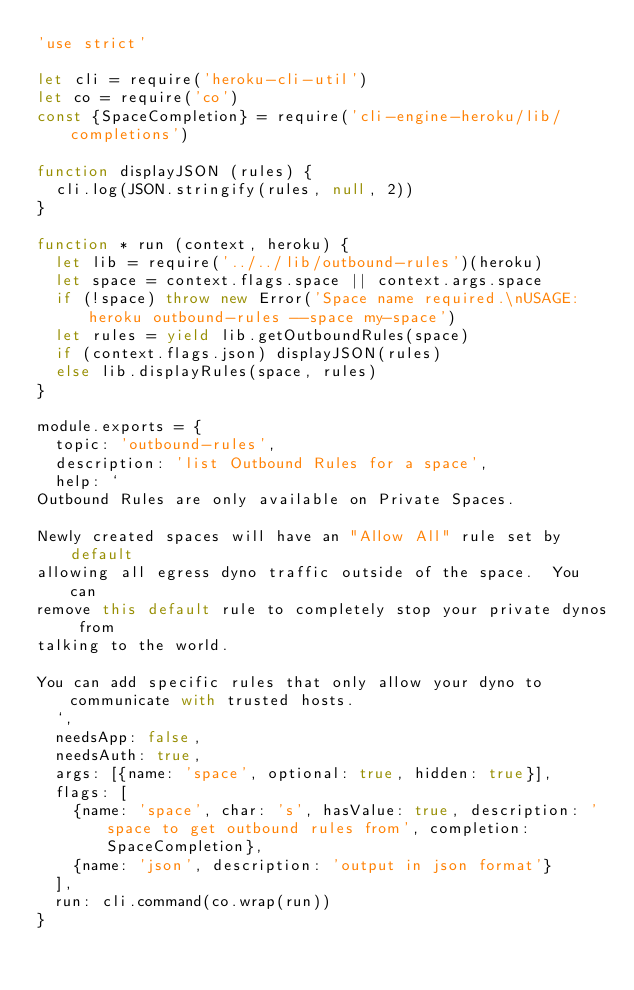Convert code to text. <code><loc_0><loc_0><loc_500><loc_500><_JavaScript_>'use strict'

let cli = require('heroku-cli-util')
let co = require('co')
const {SpaceCompletion} = require('cli-engine-heroku/lib/completions')

function displayJSON (rules) {
  cli.log(JSON.stringify(rules, null, 2))
}

function * run (context, heroku) {
  let lib = require('../../lib/outbound-rules')(heroku)
  let space = context.flags.space || context.args.space
  if (!space) throw new Error('Space name required.\nUSAGE: heroku outbound-rules --space my-space')
  let rules = yield lib.getOutboundRules(space)
  if (context.flags.json) displayJSON(rules)
  else lib.displayRules(space, rules)
}

module.exports = {
  topic: 'outbound-rules',
  description: 'list Outbound Rules for a space',
  help: `
Outbound Rules are only available on Private Spaces.

Newly created spaces will have an "Allow All" rule set by default
allowing all egress dyno traffic outside of the space.  You can
remove this default rule to completely stop your private dynos from
talking to the world.

You can add specific rules that only allow your dyno to communicate with trusted hosts.
  `,
  needsApp: false,
  needsAuth: true,
  args: [{name: 'space', optional: true, hidden: true}],
  flags: [
    {name: 'space', char: 's', hasValue: true, description: 'space to get outbound rules from', completion: SpaceCompletion},
    {name: 'json', description: 'output in json format'}
  ],
  run: cli.command(co.wrap(run))
}
</code> 